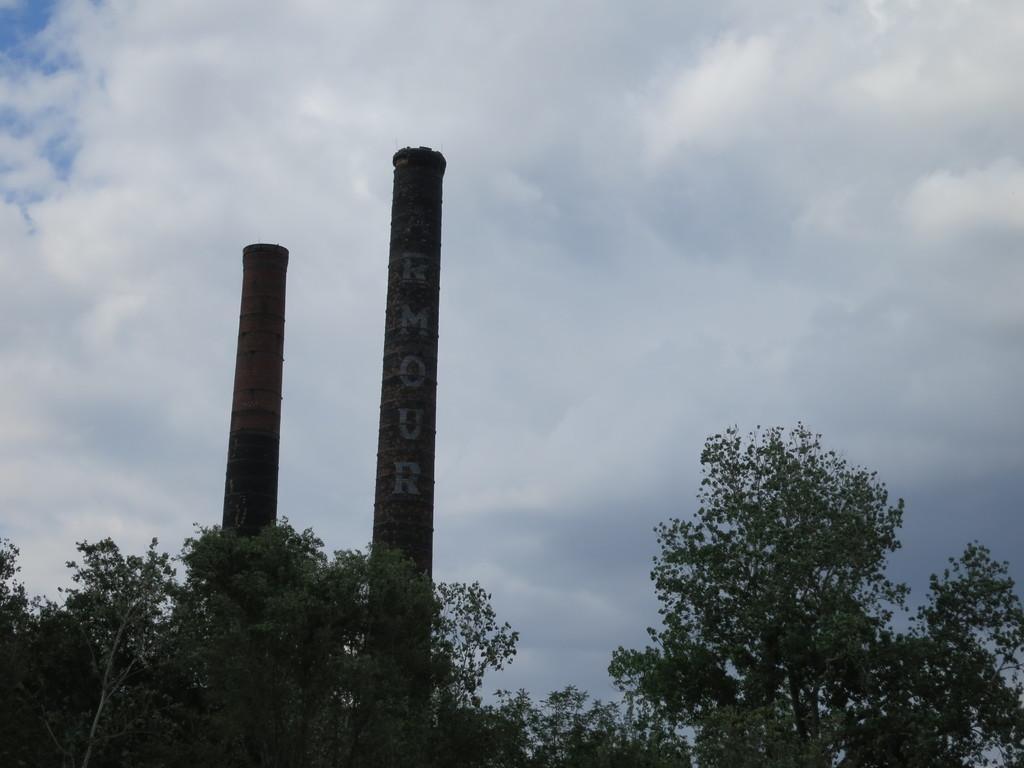How would you summarize this image in a sentence or two? In the image there are trees. And in the middle of trees there are two poles with something written on it. At the top of the image there is a sky with clouds. 